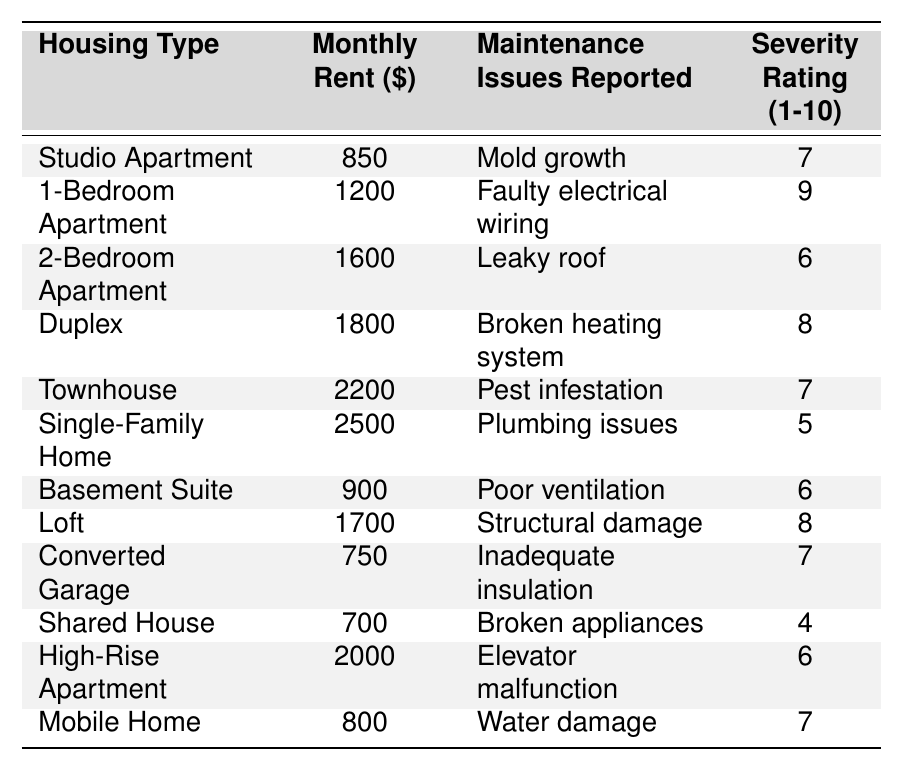What is the monthly rent of the highest-priced housing type? The highest-priced housing type listed is the Single-Family Home with a monthly rent of $2500.
Answer: $2500 How many types of housing have reported maintenance issues with a severity rating of 8 or higher? There are 3 types of housing with severity ratings of 8 or higher: the 1-Bedroom Apartment (9), Duplex (8), and Loft (8).
Answer: 3 What maintenance issue is reported for the Townhouse? The Townhouse has reported a pest infestation as its maintenance issue.
Answer: Pest infestation Which housing type has the lowest monthly rent? The Shared House is listed with the lowest monthly rent of $700.
Answer: $700 Is there a housing type that has both a lower monthly rent and less severity than the Studio Apartment? Yes, the Shared House has a lower rent ($700) and a lower severity rating (4) compared to the Studio Apartment ($850, severity 7).
Answer: Yes What is the average severity rating of all reported maintenance issues? To find the average severity rating, we add all the ratings (7 + 9 + 6 + 8 + 7 + 5 + 6 + 8 + 7 + 4 + 6 + 7 = 79) and divide by the number of housing types (12). So, the average is 79/12 = 6.58.
Answer: 6.58 How much more is the rent for a Townhouse compared to a Converted Garage? The Townhouse costs $2200 and the Converted Garage costs $750. The difference in rent is $2200 - $750 = $1450.
Answer: $1450 Which maintenance issue reported has the lowest severity rating? The Shared House has the lowest severity rating of 4 for reported broken appliances.
Answer: Broken appliances For which housing type is water damage reported? The Mobile Home is reported to have water damage as its maintenance issue.
Answer: Mobile Home 